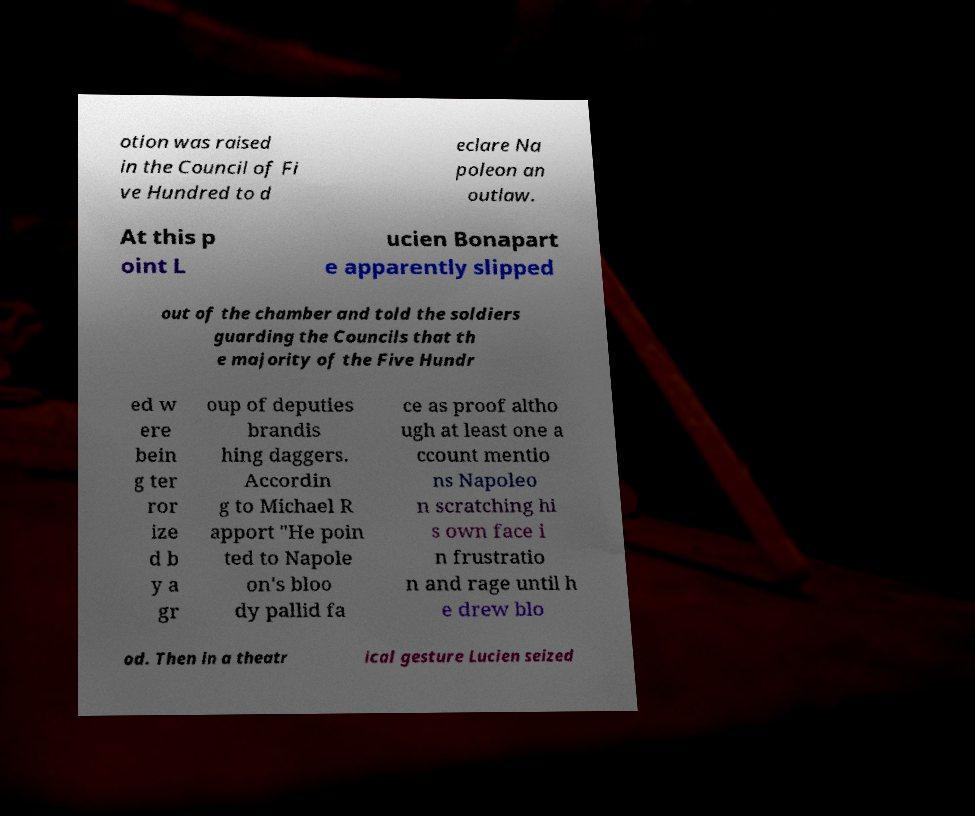Can you accurately transcribe the text from the provided image for me? otion was raised in the Council of Fi ve Hundred to d eclare Na poleon an outlaw. At this p oint L ucien Bonapart e apparently slipped out of the chamber and told the soldiers guarding the Councils that th e majority of the Five Hundr ed w ere bein g ter ror ize d b y a gr oup of deputies brandis hing daggers. Accordin g to Michael R apport "He poin ted to Napole on's bloo dy pallid fa ce as proof altho ugh at least one a ccount mentio ns Napoleo n scratching hi s own face i n frustratio n and rage until h e drew blo od. Then in a theatr ical gesture Lucien seized 